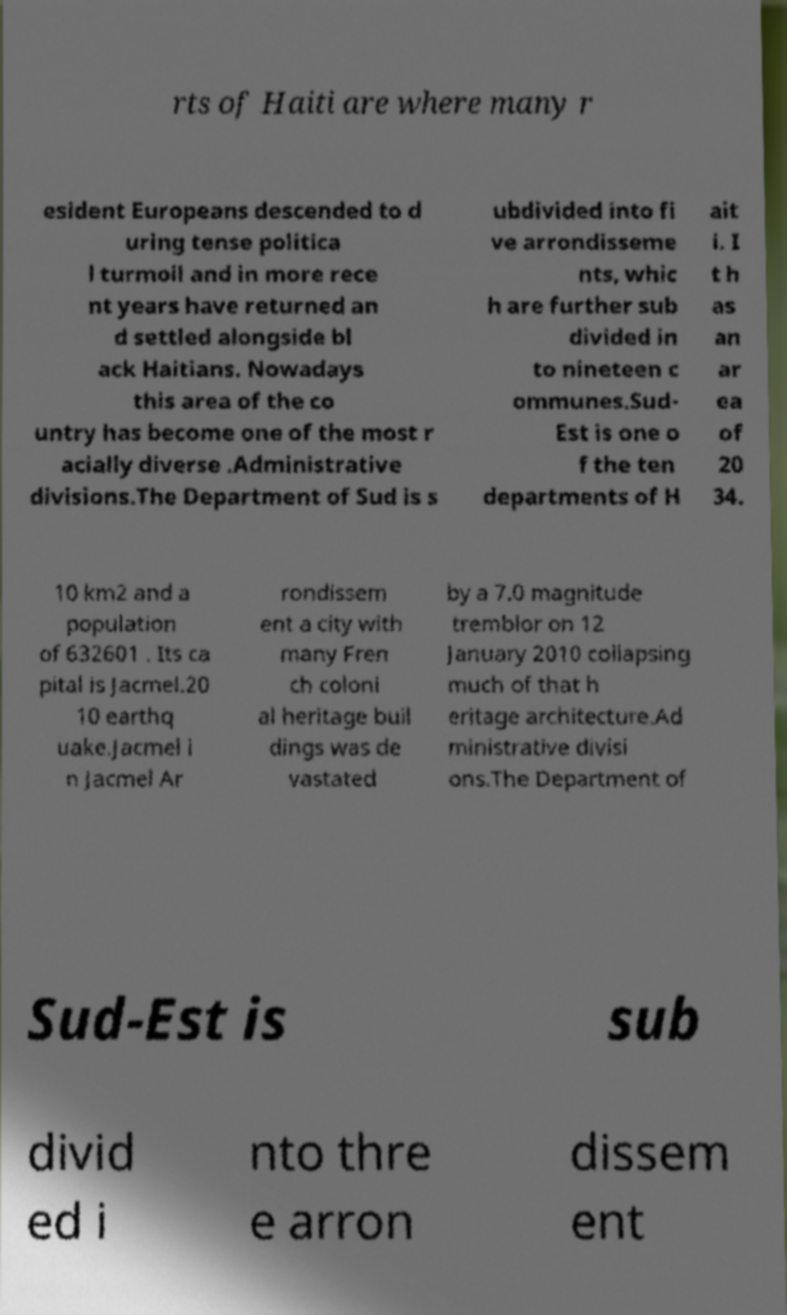There's text embedded in this image that I need extracted. Can you transcribe it verbatim? rts of Haiti are where many r esident Europeans descended to d uring tense politica l turmoil and in more rece nt years have returned an d settled alongside bl ack Haitians. Nowadays this area of the co untry has become one of the most r acially diverse .Administrative divisions.The Department of Sud is s ubdivided into fi ve arrondisseme nts, whic h are further sub divided in to nineteen c ommunes.Sud- Est is one o f the ten departments of H ait i. I t h as an ar ea of 20 34. 10 km2 and a population of 632601 . Its ca pital is Jacmel.20 10 earthq uake.Jacmel i n Jacmel Ar rondissem ent a city with many Fren ch coloni al heritage buil dings was de vastated by a 7.0 magnitude tremblor on 12 January 2010 collapsing much of that h eritage architecture.Ad ministrative divisi ons.The Department of Sud-Est is sub divid ed i nto thre e arron dissem ent 